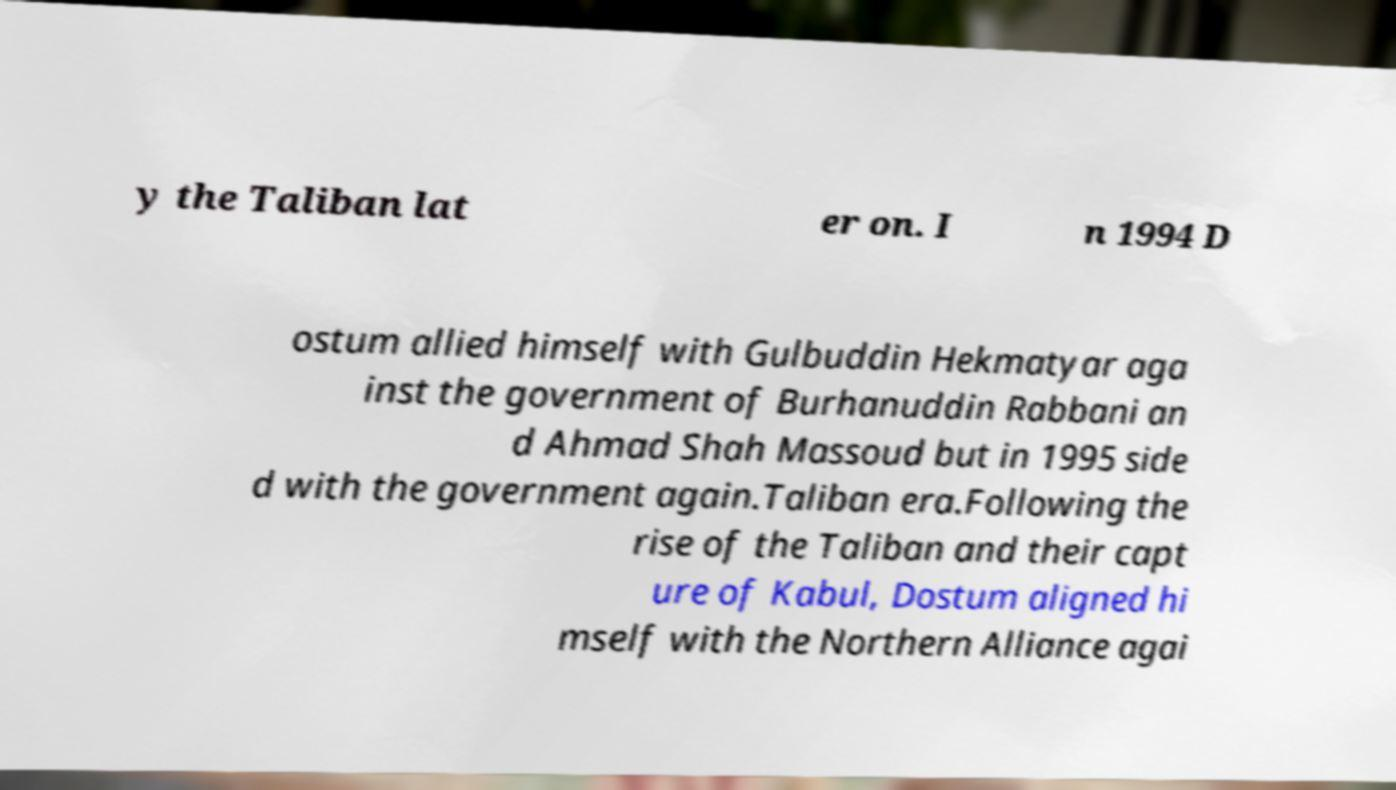Could you extract and type out the text from this image? y the Taliban lat er on. I n 1994 D ostum allied himself with Gulbuddin Hekmatyar aga inst the government of Burhanuddin Rabbani an d Ahmad Shah Massoud but in 1995 side d with the government again.Taliban era.Following the rise of the Taliban and their capt ure of Kabul, Dostum aligned hi mself with the Northern Alliance agai 